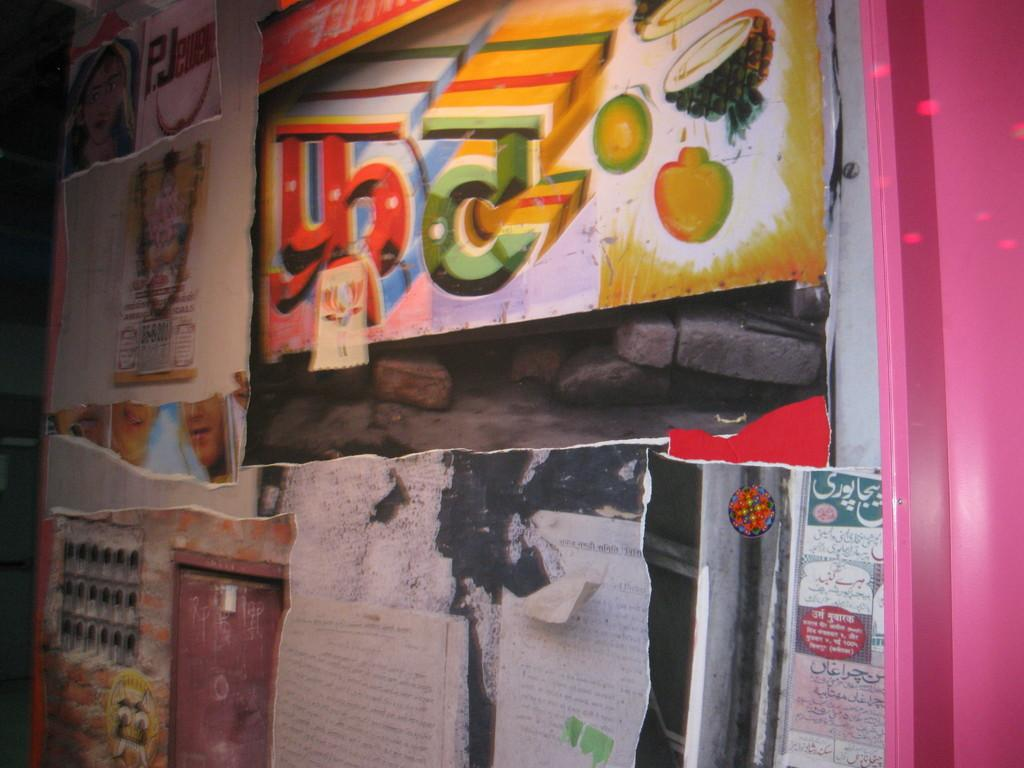What is present on the wall in the image? The wall has posters and papers attached to it. Can you describe the posters on the wall? Unfortunately, the details of the posters cannot be determined from the image alone. What type of papers are attached to the wall? The type of papers cannot be determined from the image alone. How many pies are displayed on the wall in the image? There are no pies present on the wall in the image. 